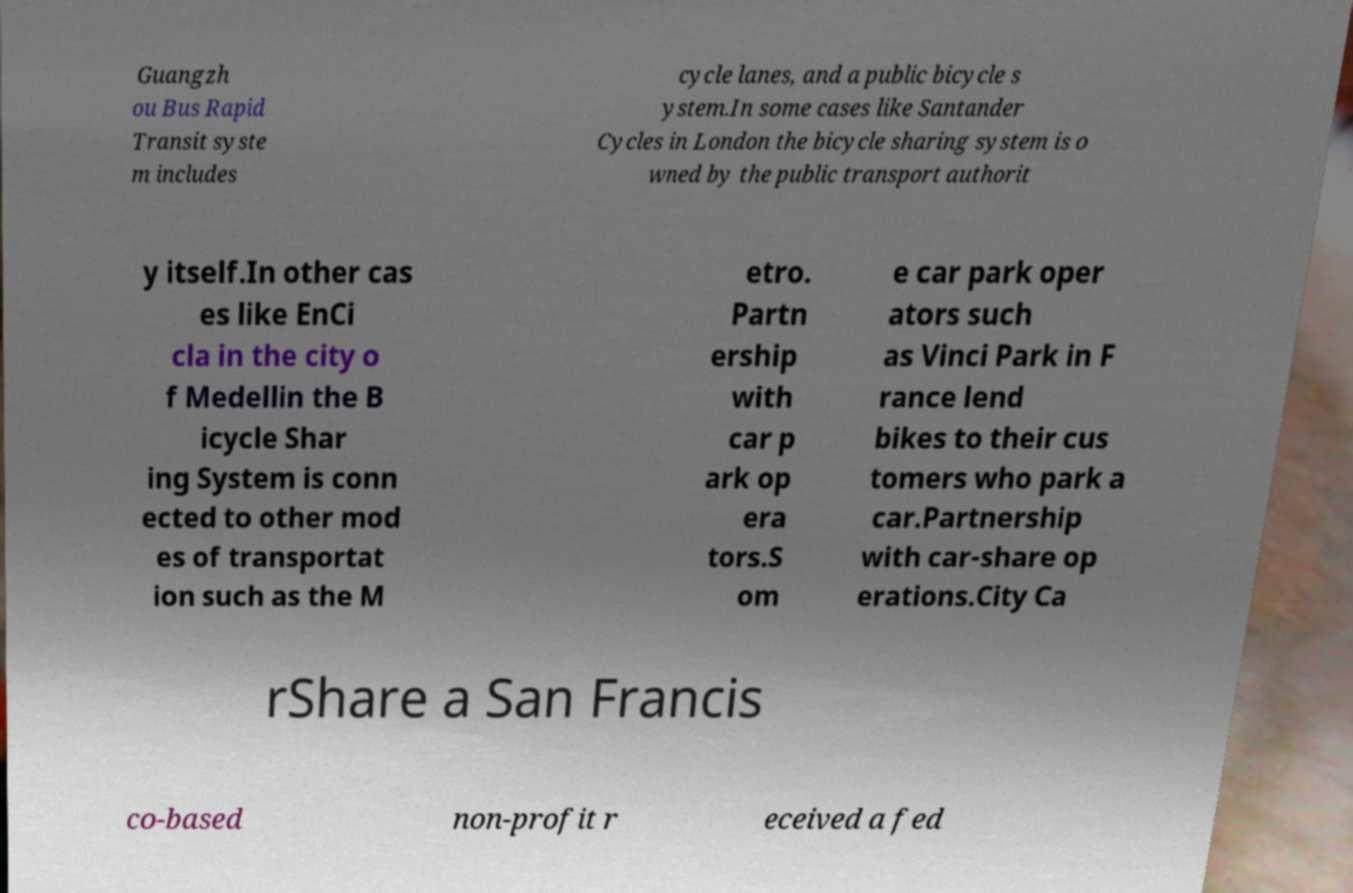Please read and relay the text visible in this image. What does it say? Guangzh ou Bus Rapid Transit syste m includes cycle lanes, and a public bicycle s ystem.In some cases like Santander Cycles in London the bicycle sharing system is o wned by the public transport authorit y itself.In other cas es like EnCi cla in the city o f Medellin the B icycle Shar ing System is conn ected to other mod es of transportat ion such as the M etro. Partn ership with car p ark op era tors.S om e car park oper ators such as Vinci Park in F rance lend bikes to their cus tomers who park a car.Partnership with car-share op erations.City Ca rShare a San Francis co-based non-profit r eceived a fed 